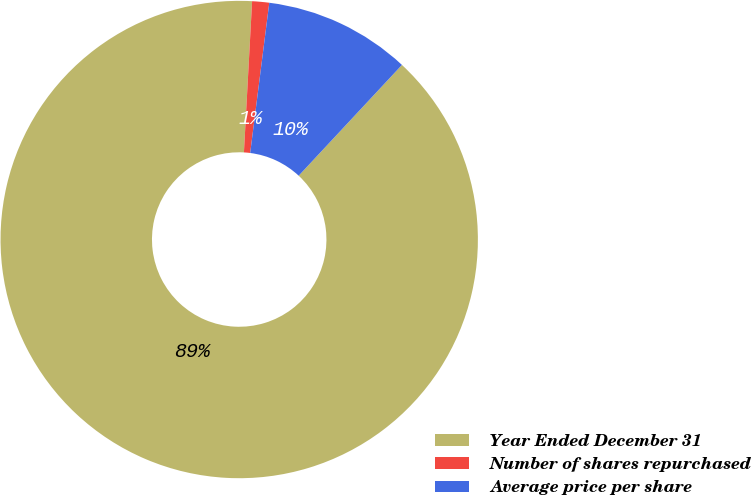Convert chart to OTSL. <chart><loc_0><loc_0><loc_500><loc_500><pie_chart><fcel>Year Ended December 31<fcel>Number of shares repurchased<fcel>Average price per share<nl><fcel>88.92%<fcel>1.15%<fcel>9.93%<nl></chart> 